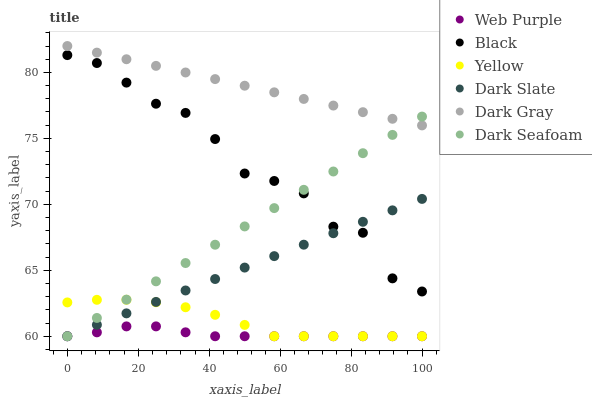Does Web Purple have the minimum area under the curve?
Answer yes or no. Yes. Does Dark Gray have the maximum area under the curve?
Answer yes or no. Yes. Does Yellow have the minimum area under the curve?
Answer yes or no. No. Does Yellow have the maximum area under the curve?
Answer yes or no. No. Is Dark Seafoam the smoothest?
Answer yes or no. Yes. Is Black the roughest?
Answer yes or no. Yes. Is Yellow the smoothest?
Answer yes or no. No. Is Yellow the roughest?
Answer yes or no. No. Does Dark Seafoam have the lowest value?
Answer yes or no. Yes. Does Dark Gray have the lowest value?
Answer yes or no. No. Does Dark Gray have the highest value?
Answer yes or no. Yes. Does Yellow have the highest value?
Answer yes or no. No. Is Yellow less than Dark Gray?
Answer yes or no. Yes. Is Dark Gray greater than Yellow?
Answer yes or no. Yes. Does Dark Seafoam intersect Web Purple?
Answer yes or no. Yes. Is Dark Seafoam less than Web Purple?
Answer yes or no. No. Is Dark Seafoam greater than Web Purple?
Answer yes or no. No. Does Yellow intersect Dark Gray?
Answer yes or no. No. 